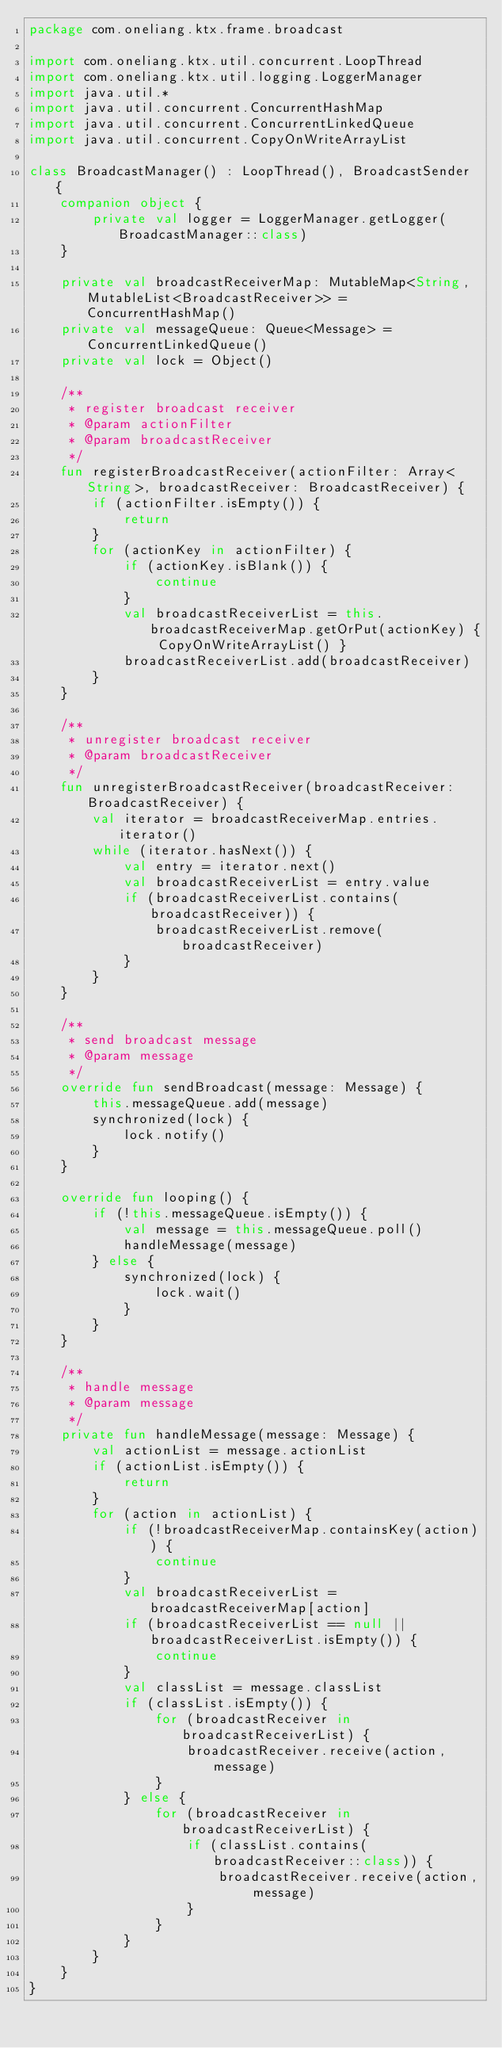Convert code to text. <code><loc_0><loc_0><loc_500><loc_500><_Kotlin_>package com.oneliang.ktx.frame.broadcast

import com.oneliang.ktx.util.concurrent.LoopThread
import com.oneliang.ktx.util.logging.LoggerManager
import java.util.*
import java.util.concurrent.ConcurrentHashMap
import java.util.concurrent.ConcurrentLinkedQueue
import java.util.concurrent.CopyOnWriteArrayList

class BroadcastManager() : LoopThread(), BroadcastSender {
    companion object {
        private val logger = LoggerManager.getLogger(BroadcastManager::class)
    }

    private val broadcastReceiverMap: MutableMap<String, MutableList<BroadcastReceiver>> = ConcurrentHashMap()
    private val messageQueue: Queue<Message> = ConcurrentLinkedQueue()
    private val lock = Object()

    /**
     * register broadcast receiver
     * @param actionFilter
     * @param broadcastReceiver
     */
    fun registerBroadcastReceiver(actionFilter: Array<String>, broadcastReceiver: BroadcastReceiver) {
        if (actionFilter.isEmpty()) {
            return
        }
        for (actionKey in actionFilter) {
            if (actionKey.isBlank()) {
                continue
            }
            val broadcastReceiverList = this.broadcastReceiverMap.getOrPut(actionKey) { CopyOnWriteArrayList() }
            broadcastReceiverList.add(broadcastReceiver)
        }
    }

    /**
     * unregister broadcast receiver
     * @param broadcastReceiver
     */
    fun unregisterBroadcastReceiver(broadcastReceiver: BroadcastReceiver) {
        val iterator = broadcastReceiverMap.entries.iterator()
        while (iterator.hasNext()) {
            val entry = iterator.next()
            val broadcastReceiverList = entry.value
            if (broadcastReceiverList.contains(broadcastReceiver)) {
                broadcastReceiverList.remove(broadcastReceiver)
            }
        }
    }

    /**
     * send broadcast message
     * @param message
     */
    override fun sendBroadcast(message: Message) {
        this.messageQueue.add(message)
        synchronized(lock) {
            lock.notify()
        }
    }

    override fun looping() {
        if (!this.messageQueue.isEmpty()) {
            val message = this.messageQueue.poll()
            handleMessage(message)
        } else {
            synchronized(lock) {
                lock.wait()
            }
        }
    }

    /**
     * handle message
     * @param message
     */
    private fun handleMessage(message: Message) {
        val actionList = message.actionList
        if (actionList.isEmpty()) {
            return
        }
        for (action in actionList) {
            if (!broadcastReceiverMap.containsKey(action)) {
                continue
            }
            val broadcastReceiverList = broadcastReceiverMap[action]
            if (broadcastReceiverList == null || broadcastReceiverList.isEmpty()) {
                continue
            }
            val classList = message.classList
            if (classList.isEmpty()) {
                for (broadcastReceiver in broadcastReceiverList) {
                    broadcastReceiver.receive(action, message)
                }
            } else {
                for (broadcastReceiver in broadcastReceiverList) {
                    if (classList.contains(broadcastReceiver::class)) {
                        broadcastReceiver.receive(action, message)
                    }
                }
            }
        }
    }
}
</code> 